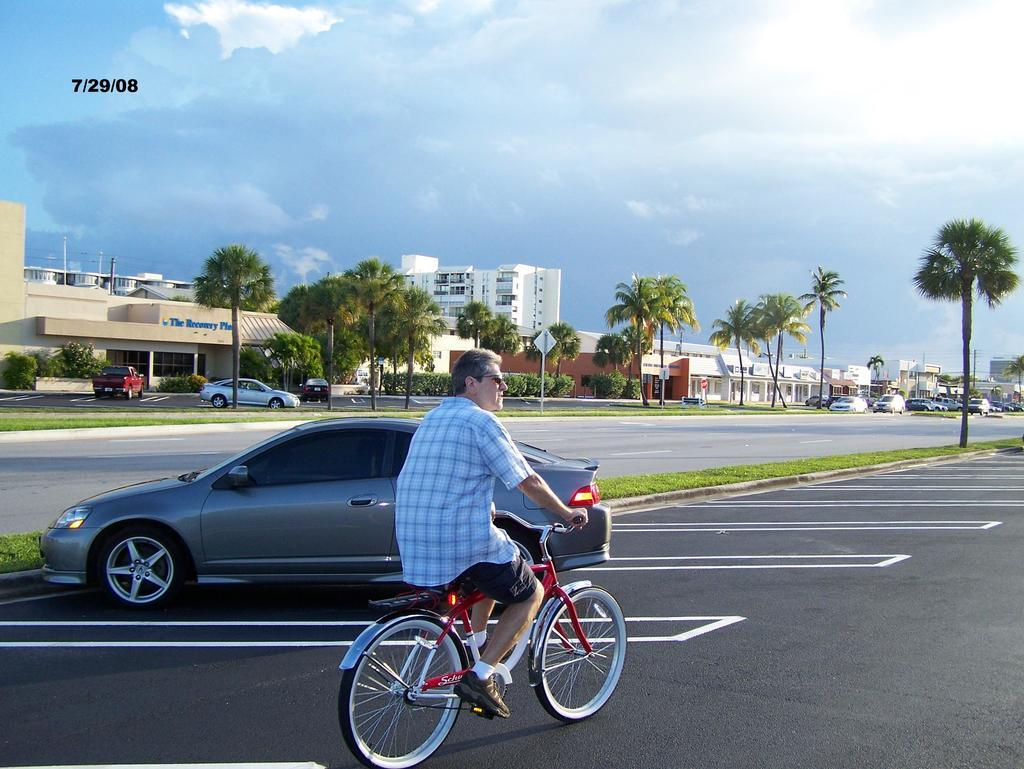What is the man doing in the image? The man is riding a bicycle on the road. What can be seen on the left side of the road? There is a car parked on the left side of the road. What structures are visible in the background? There is a house and a building in the background. What type of vegetation is present in the background? There is a tree in the background. What is visible in the sky in the image? The sky is visible with clouds in the background. What type of yak can be seen grazing on the side of the road in the image? There is no yak present in the image; it features a man riding a bicycle on the road. What type of curve is visible on the road in the image? There is no curve visible on the road in the image; it is a straight road. 